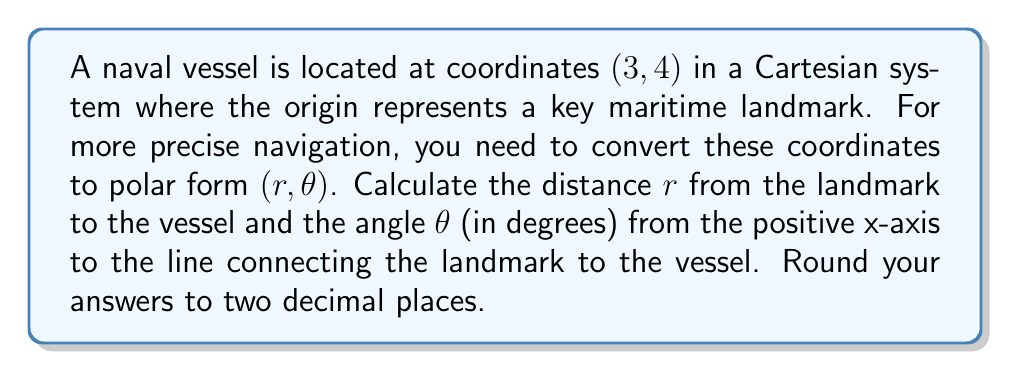Give your solution to this math problem. To convert from Cartesian coordinates $(x, y)$ to polar coordinates $(r, \theta)$, we use the following formulas:

1. For the radius $r$:
   $$r = \sqrt{x^2 + y^2}$$

2. For the angle $\theta$ (in radians):
   $$\theta = \tan^{-1}\left(\frac{y}{x}\right)$$

   Note: We need to be careful with the quadrant when calculating $\theta$.

Let's solve step by step:

1. Calculate $r$:
   $$r = \sqrt{3^2 + 4^2} = \sqrt{9 + 16} = \sqrt{25} = 5$$

2. Calculate $\theta$ in radians:
   $$\theta = \tan^{-1}\left(\frac{4}{3}\right) \approx 0.9273 \text{ radians}$$

3. Convert $\theta$ to degrees:
   $$\theta \text{ in degrees} = 0.9273 \times \frac{180^\circ}{\pi} \approx 53.13^\circ$$

The vessel is in the first quadrant, so no adjustment to $\theta$ is needed.

[asy]
import geometry;

size(200);
defaultpen(fontsize(10pt));

pair O=(0,0), P=(3,4);
draw((-1,0)--(4,0), arrow=Arrow(TeXHead));
draw((0,-1)--(0,5), arrow=Arrow(TeXHead));
draw(O--P, arrow=Arrow(TeXHead));

dot("O", O, SW);
dot("P (3, 4)", P, NE);

draw(arc(O, 0.8, 0, degrees(atan2(4,3))), arrow=Arrow(TeXHead));
label("$\theta$", (0.5,0.3));

label("x", (4,0), S);
label("y", (0,5), W);
[/asy]
Answer: $r = 5.00$, $\theta = 53.13^\circ$ 